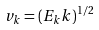<formula> <loc_0><loc_0><loc_500><loc_500>v _ { k } = ( E _ { k } k ) ^ { 1 / 2 }</formula> 